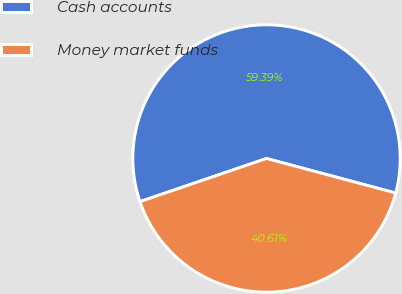<chart> <loc_0><loc_0><loc_500><loc_500><pie_chart><fcel>Cash accounts<fcel>Money market funds<nl><fcel>59.39%<fcel>40.61%<nl></chart> 